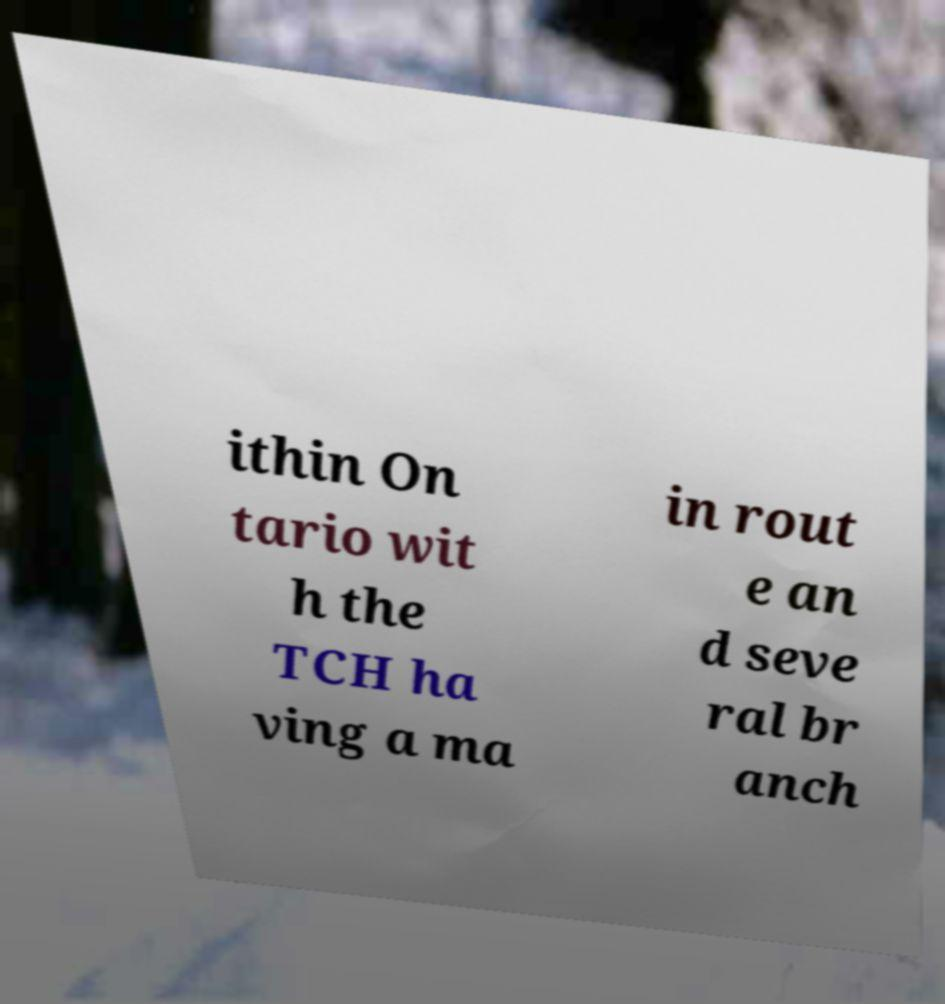Can you accurately transcribe the text from the provided image for me? ithin On tario wit h the TCH ha ving a ma in rout e an d seve ral br anch 